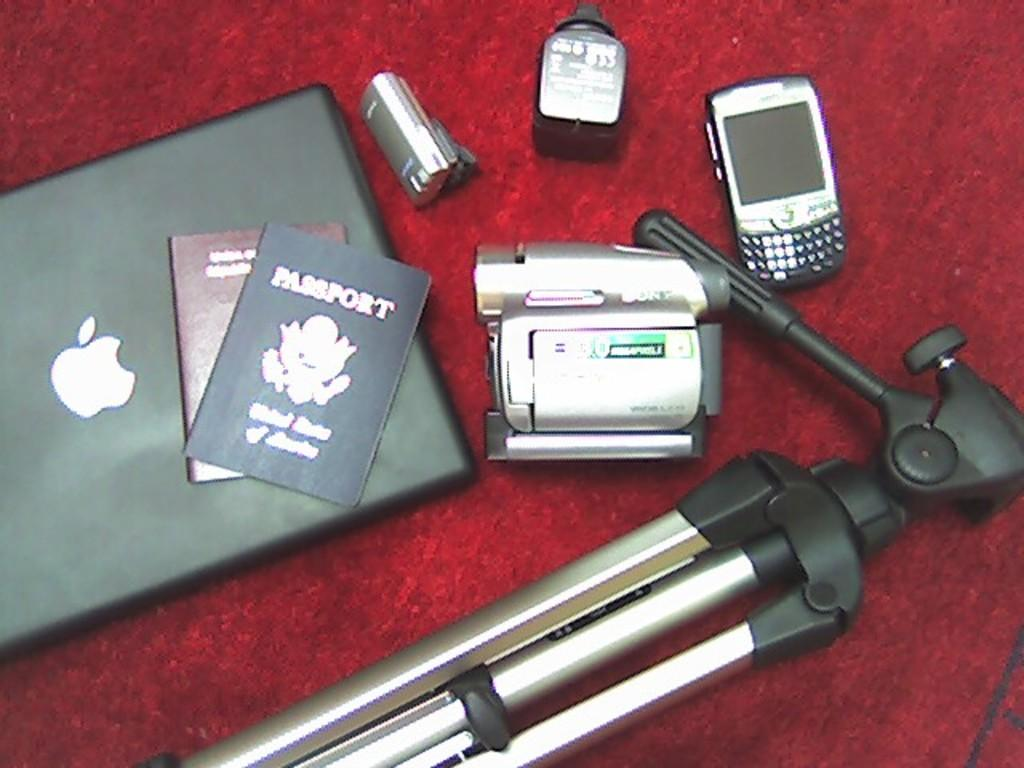Provide a one-sentence caption for the provided image. A United States of America Passport sits on top of an Apple computer. 